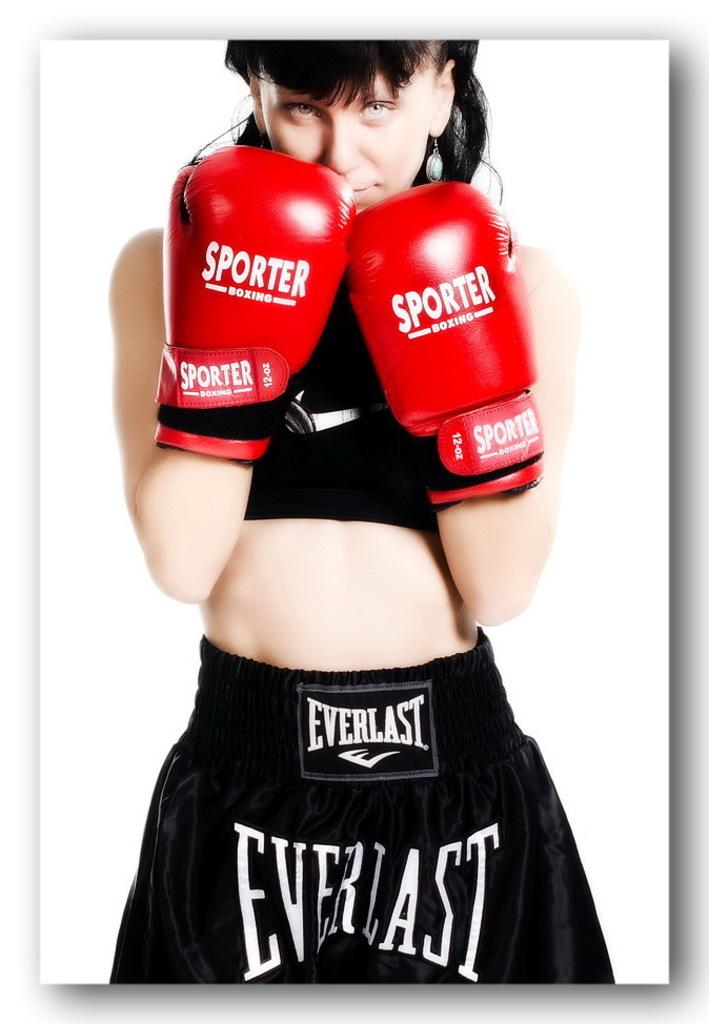<image>
Present a compact description of the photo's key features. a woman boxer wearing red gloves labeled 'sporter' 